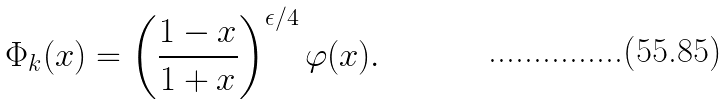Convert formula to latex. <formula><loc_0><loc_0><loc_500><loc_500>\Phi _ { k } ( x ) = \left ( \frac { 1 - x } { 1 + x } \right ) ^ { \epsilon / 4 } \varphi ( x ) .</formula> 